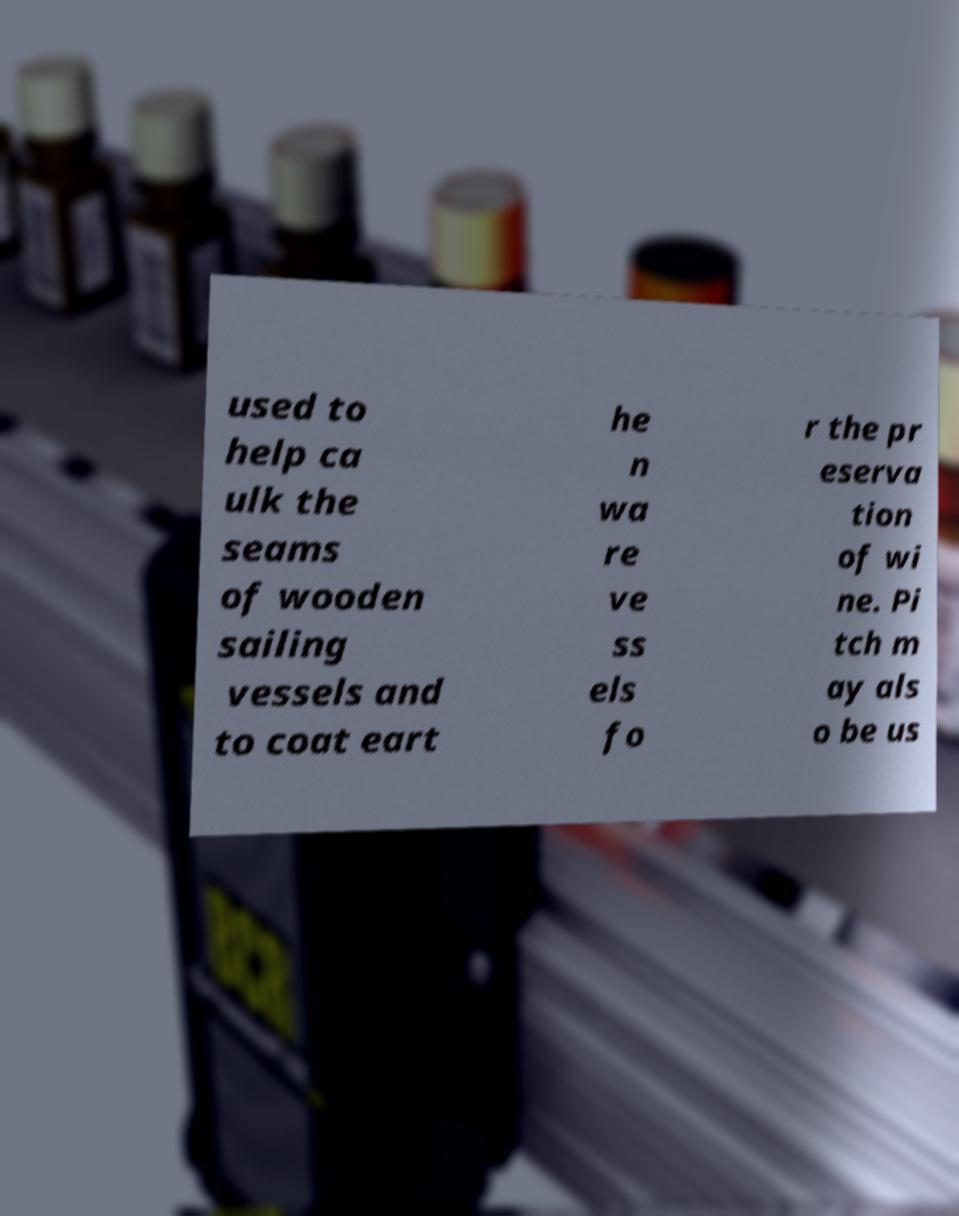There's text embedded in this image that I need extracted. Can you transcribe it verbatim? used to help ca ulk the seams of wooden sailing vessels and to coat eart he n wa re ve ss els fo r the pr eserva tion of wi ne. Pi tch m ay als o be us 